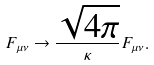Convert formula to latex. <formula><loc_0><loc_0><loc_500><loc_500>F _ { \mu \nu } \to \frac { \sqrt { 4 \pi } } { \kappa } F _ { \mu \nu } .</formula> 